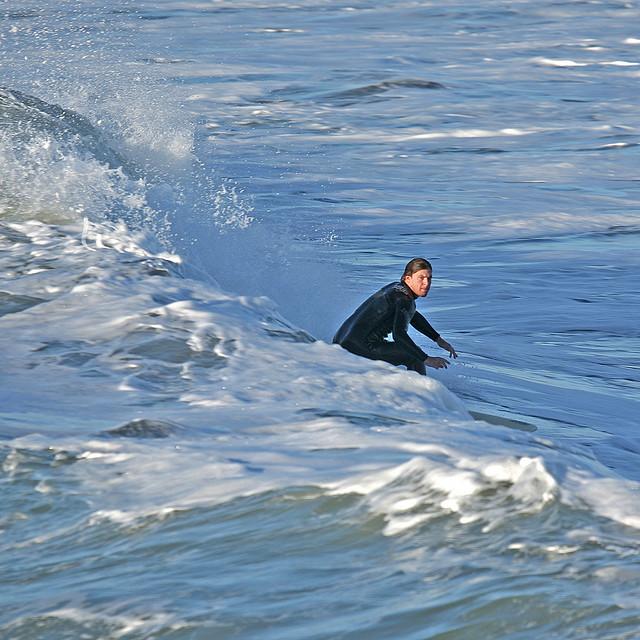Is she going very fast?
Write a very short answer. No. Was this picture taken in Miami, Florida?
Concise answer only. No. How many surfers in the water?
Concise answer only. 1. Are the wave roiling?
Short answer required. Yes. Did the surfer catch a wave?
Keep it brief. Yes. What is the gender of the person?
Short answer required. Male. What sport is this?
Give a very brief answer. Surfing. 